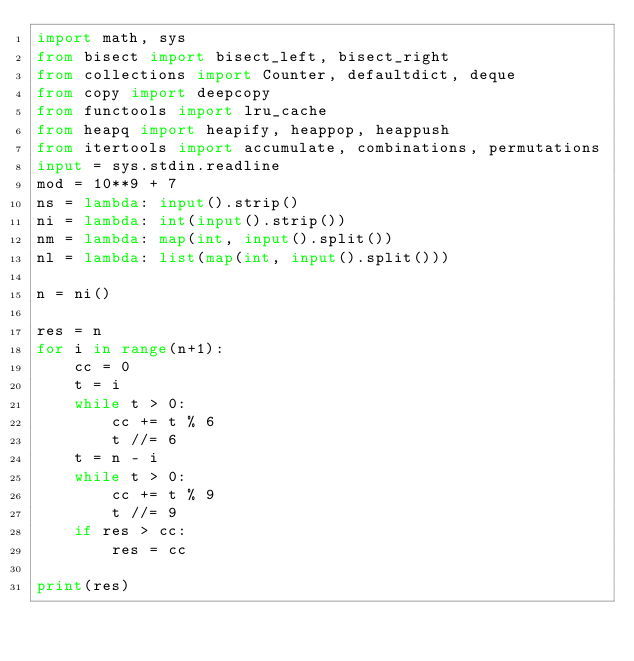<code> <loc_0><loc_0><loc_500><loc_500><_Python_>import math, sys
from bisect import bisect_left, bisect_right
from collections import Counter, defaultdict, deque
from copy import deepcopy
from functools import lru_cache
from heapq import heapify, heappop, heappush
from itertools import accumulate, combinations, permutations
input = sys.stdin.readline
mod = 10**9 + 7
ns = lambda: input().strip()
ni = lambda: int(input().strip())
nm = lambda: map(int, input().split())
nl = lambda: list(map(int, input().split()))

n = ni()

res = n
for i in range(n+1):
    cc = 0
    t = i
    while t > 0:
        cc += t % 6
        t //= 6
    t = n - i
    while t > 0:
        cc += t % 9
        t //= 9
    if res > cc:
        res = cc

print(res)</code> 